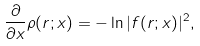Convert formula to latex. <formula><loc_0><loc_0><loc_500><loc_500>\frac { \partial } { \partial x } \rho ( r ; x ) = - \ln | f ( r ; x ) | ^ { 2 } ,</formula> 